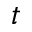Convert formula to latex. <formula><loc_0><loc_0><loc_500><loc_500>t</formula> 